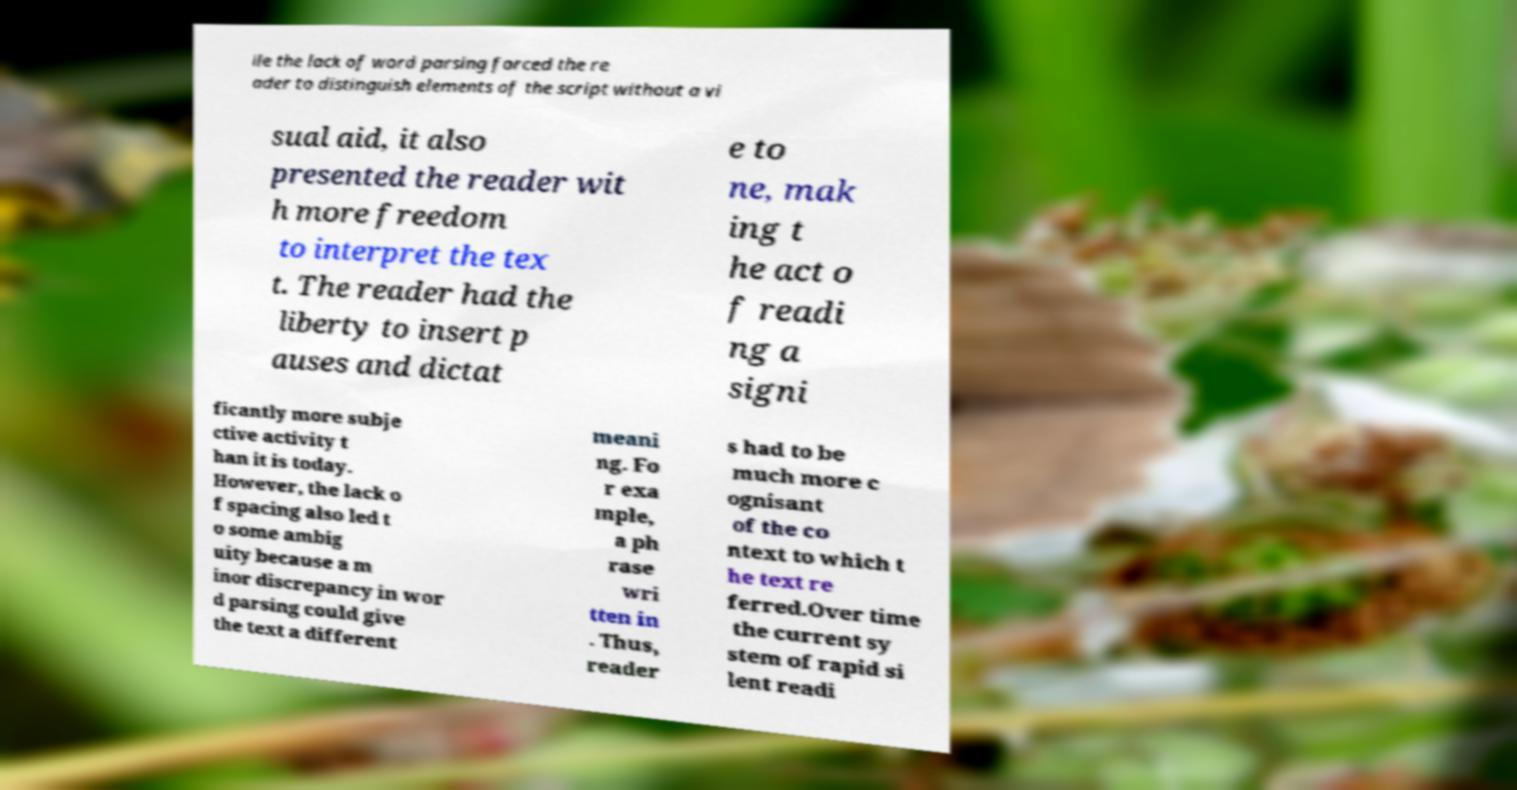Please read and relay the text visible in this image. What does it say? ile the lack of word parsing forced the re ader to distinguish elements of the script without a vi sual aid, it also presented the reader wit h more freedom to interpret the tex t. The reader had the liberty to insert p auses and dictat e to ne, mak ing t he act o f readi ng a signi ficantly more subje ctive activity t han it is today. However, the lack o f spacing also led t o some ambig uity because a m inor discrepancy in wor d parsing could give the text a different meani ng. Fo r exa mple, a ph rase wri tten in . Thus, reader s had to be much more c ognisant of the co ntext to which t he text re ferred.Over time the current sy stem of rapid si lent readi 